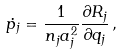Convert formula to latex. <formula><loc_0><loc_0><loc_500><loc_500>\dot { p _ { j } } = { { \frac { 1 } { n _ { j } a _ { j } ^ { 2 } } } { \frac { \partial R _ { j } } { \partial q _ { j } } } } \, ,</formula> 